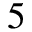Convert formula to latex. <formula><loc_0><loc_0><loc_500><loc_500>5</formula> 